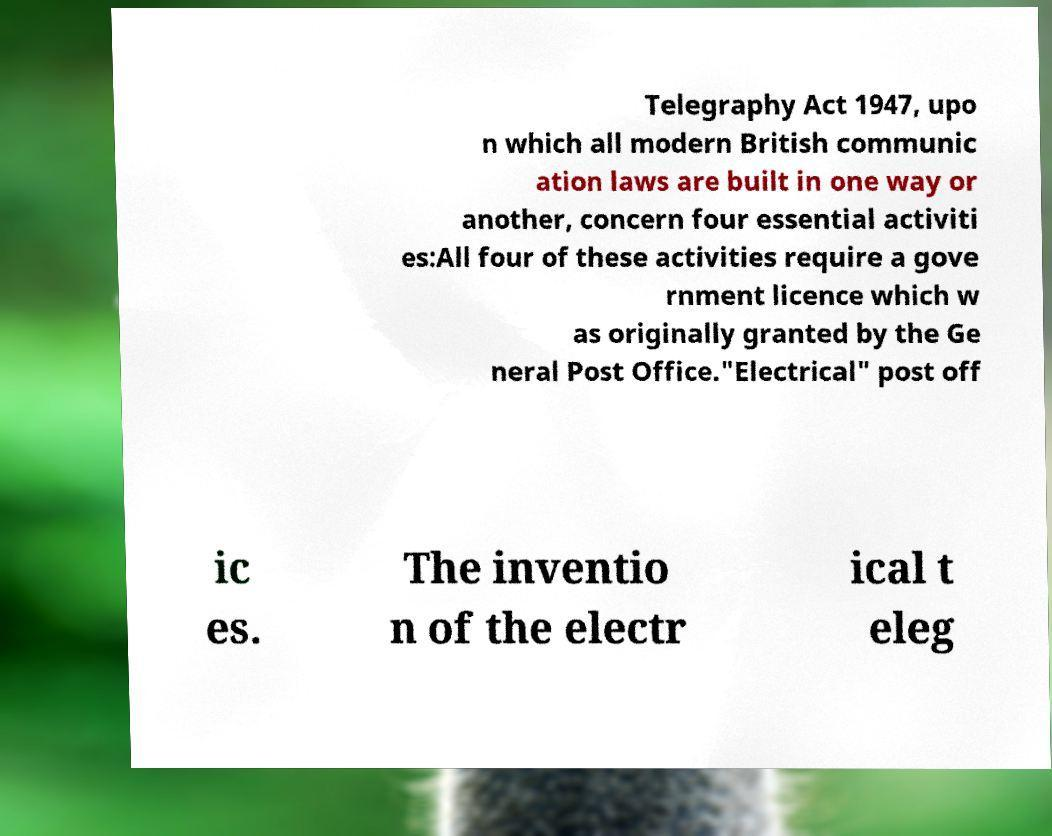For documentation purposes, I need the text within this image transcribed. Could you provide that? Telegraphy Act 1947, upo n which all modern British communic ation laws are built in one way or another, concern four essential activiti es:All four of these activities require a gove rnment licence which w as originally granted by the Ge neral Post Office."Electrical" post off ic es. The inventio n of the electr ical t eleg 